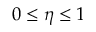<formula> <loc_0><loc_0><loc_500><loc_500>0 \leq \eta \leq 1</formula> 